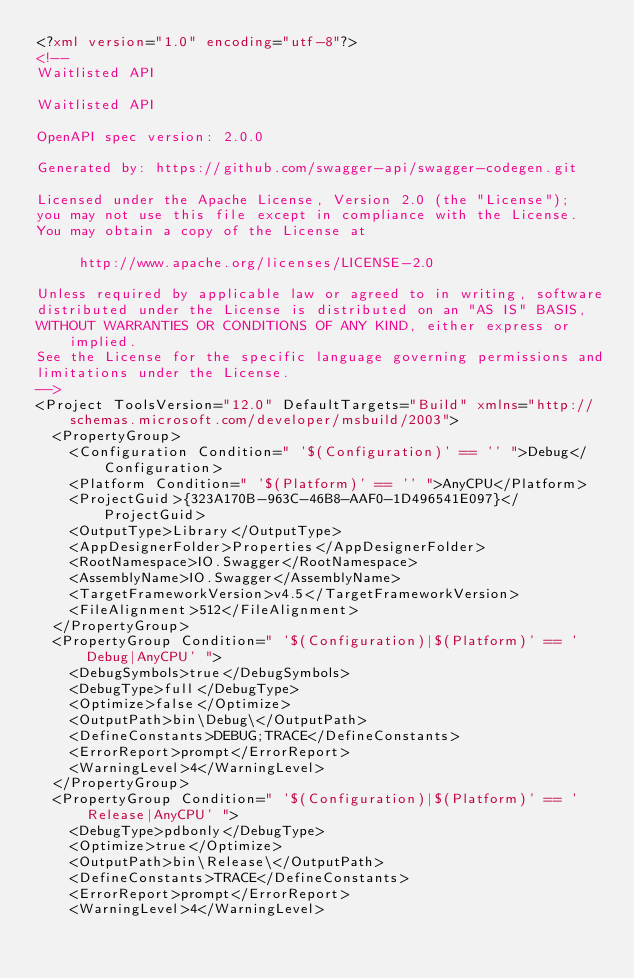Convert code to text. <code><loc_0><loc_0><loc_500><loc_500><_XML_><?xml version="1.0" encoding="utf-8"?>
<!--
Waitlisted API

Waitlisted API

OpenAPI spec version: 2.0.0

Generated by: https://github.com/swagger-api/swagger-codegen.git

Licensed under the Apache License, Version 2.0 (the "License");
you may not use this file except in compliance with the License.
You may obtain a copy of the License at

     http://www.apache.org/licenses/LICENSE-2.0

Unless required by applicable law or agreed to in writing, software
distributed under the License is distributed on an "AS IS" BASIS,
WITHOUT WARRANTIES OR CONDITIONS OF ANY KIND, either express or implied.
See the License for the specific language governing permissions and
limitations under the License.
-->
<Project ToolsVersion="12.0" DefaultTargets="Build" xmlns="http://schemas.microsoft.com/developer/msbuild/2003">
  <PropertyGroup>
    <Configuration Condition=" '$(Configuration)' == '' ">Debug</Configuration>
    <Platform Condition=" '$(Platform)' == '' ">AnyCPU</Platform>
    <ProjectGuid>{323A170B-963C-46B8-AAF0-1D496541E097}</ProjectGuid>
    <OutputType>Library</OutputType>
    <AppDesignerFolder>Properties</AppDesignerFolder>
    <RootNamespace>IO.Swagger</RootNamespace>
    <AssemblyName>IO.Swagger</AssemblyName>
    <TargetFrameworkVersion>v4.5</TargetFrameworkVersion>
    <FileAlignment>512</FileAlignment>
  </PropertyGroup>
  <PropertyGroup Condition=" '$(Configuration)|$(Platform)' == 'Debug|AnyCPU' ">
    <DebugSymbols>true</DebugSymbols>
    <DebugType>full</DebugType>
    <Optimize>false</Optimize>
    <OutputPath>bin\Debug\</OutputPath>
    <DefineConstants>DEBUG;TRACE</DefineConstants>
    <ErrorReport>prompt</ErrorReport>
    <WarningLevel>4</WarningLevel>
  </PropertyGroup>
  <PropertyGroup Condition=" '$(Configuration)|$(Platform)' == 'Release|AnyCPU' ">
    <DebugType>pdbonly</DebugType>
    <Optimize>true</Optimize>
    <OutputPath>bin\Release\</OutputPath>
    <DefineConstants>TRACE</DefineConstants>
    <ErrorReport>prompt</ErrorReport>
    <WarningLevel>4</WarningLevel></code> 